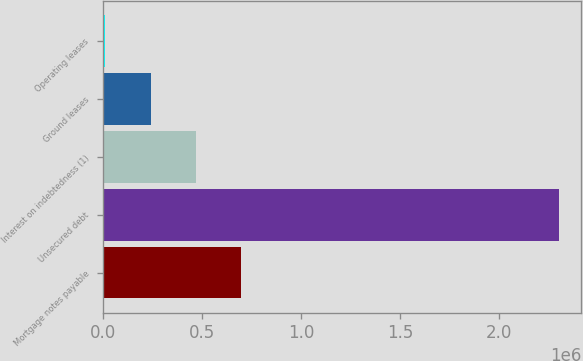Convert chart. <chart><loc_0><loc_0><loc_500><loc_500><bar_chart><fcel>Mortgage notes payable<fcel>Unsecured debt<fcel>Interest on indebtedness (1)<fcel>Ground leases<fcel>Operating leases<nl><fcel>698645<fcel>2.3e+06<fcel>469880<fcel>241115<fcel>12350<nl></chart> 